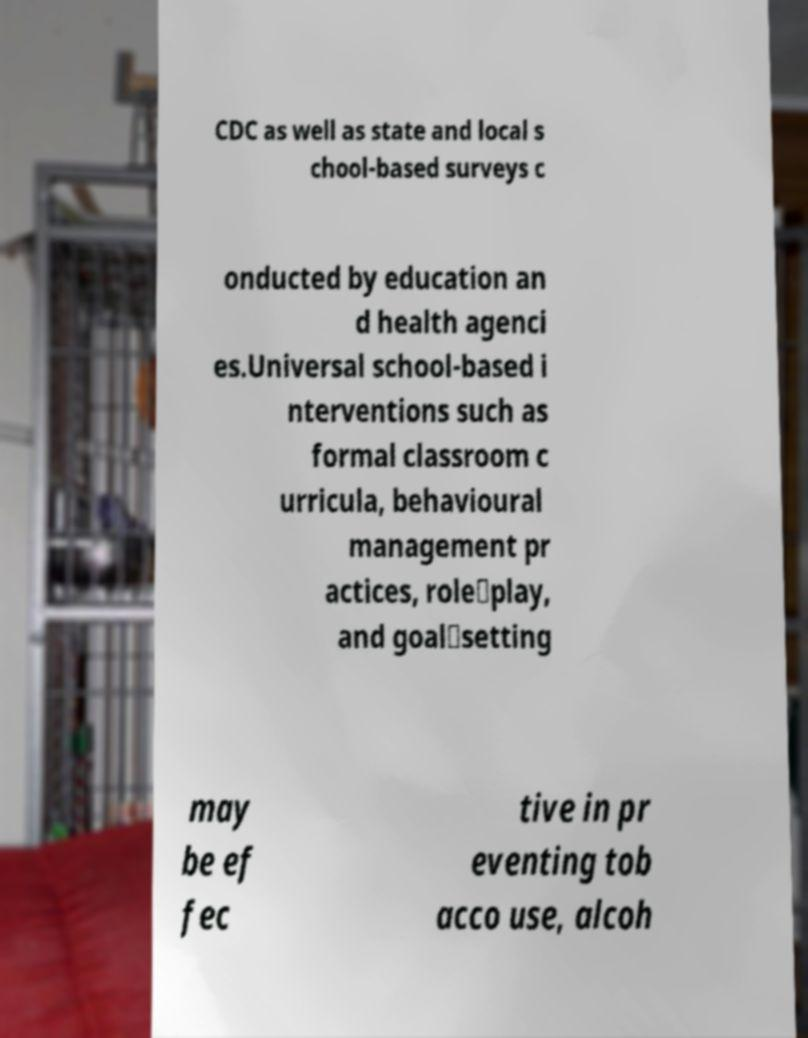Can you accurately transcribe the text from the provided image for me? CDC as well as state and local s chool-based surveys c onducted by education an d health agenci es.Universal school-based i nterventions such as formal classroom c urricula, behavioural management pr actices, role‐play, and goal‐setting may be ef fec tive in pr eventing tob acco use, alcoh 